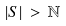Convert formula to latex. <formula><loc_0><loc_0><loc_500><loc_500>| S | \, > \, \mathbb { N }</formula> 